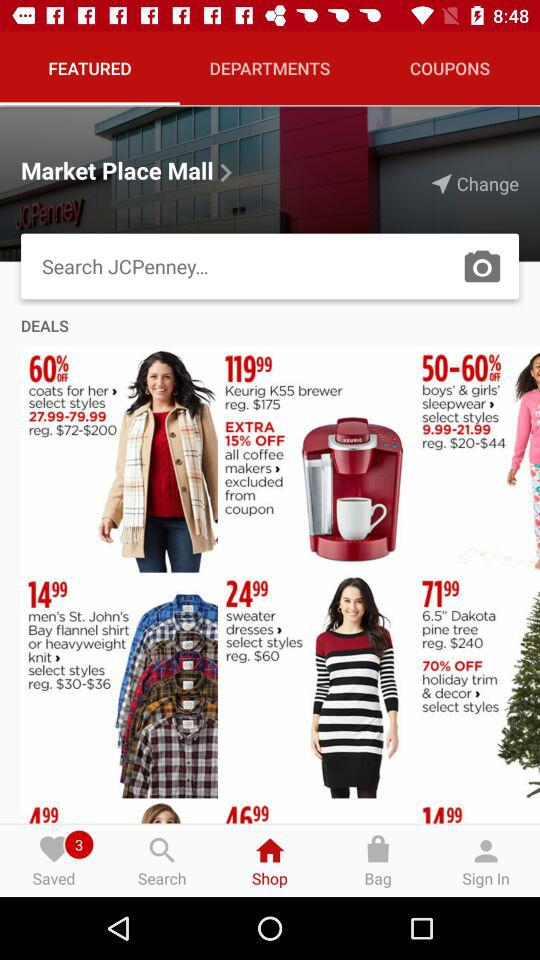What is the discounted price range for "coats"? The discounted price range for "coats" is $27.99-79.99. 